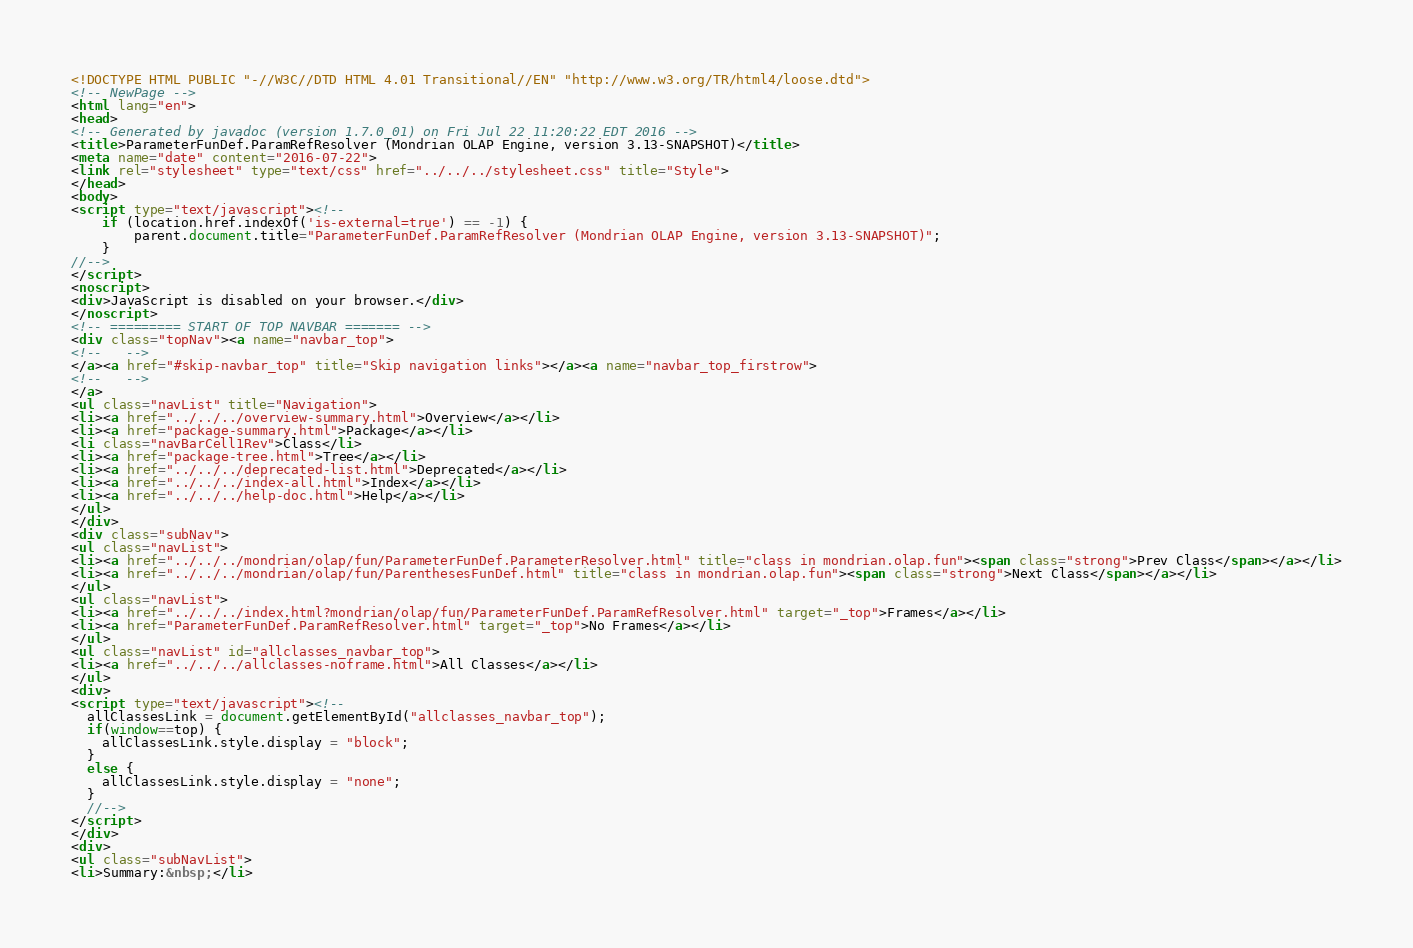<code> <loc_0><loc_0><loc_500><loc_500><_HTML_><!DOCTYPE HTML PUBLIC "-//W3C//DTD HTML 4.01 Transitional//EN" "http://www.w3.org/TR/html4/loose.dtd">
<!-- NewPage -->
<html lang="en">
<head>
<!-- Generated by javadoc (version 1.7.0_01) on Fri Jul 22 11:20:22 EDT 2016 -->
<title>ParameterFunDef.ParamRefResolver (Mondrian OLAP Engine, version 3.13-SNAPSHOT)</title>
<meta name="date" content="2016-07-22">
<link rel="stylesheet" type="text/css" href="../../../stylesheet.css" title="Style">
</head>
<body>
<script type="text/javascript"><!--
    if (location.href.indexOf('is-external=true') == -1) {
        parent.document.title="ParameterFunDef.ParamRefResolver (Mondrian OLAP Engine, version 3.13-SNAPSHOT)";
    }
//-->
</script>
<noscript>
<div>JavaScript is disabled on your browser.</div>
</noscript>
<!-- ========= START OF TOP NAVBAR ======= -->
<div class="topNav"><a name="navbar_top">
<!--   -->
</a><a href="#skip-navbar_top" title="Skip navigation links"></a><a name="navbar_top_firstrow">
<!--   -->
</a>
<ul class="navList" title="Navigation">
<li><a href="../../../overview-summary.html">Overview</a></li>
<li><a href="package-summary.html">Package</a></li>
<li class="navBarCell1Rev">Class</li>
<li><a href="package-tree.html">Tree</a></li>
<li><a href="../../../deprecated-list.html">Deprecated</a></li>
<li><a href="../../../index-all.html">Index</a></li>
<li><a href="../../../help-doc.html">Help</a></li>
</ul>
</div>
<div class="subNav">
<ul class="navList">
<li><a href="../../../mondrian/olap/fun/ParameterFunDef.ParameterResolver.html" title="class in mondrian.olap.fun"><span class="strong">Prev Class</span></a></li>
<li><a href="../../../mondrian/olap/fun/ParenthesesFunDef.html" title="class in mondrian.olap.fun"><span class="strong">Next Class</span></a></li>
</ul>
<ul class="navList">
<li><a href="../../../index.html?mondrian/olap/fun/ParameterFunDef.ParamRefResolver.html" target="_top">Frames</a></li>
<li><a href="ParameterFunDef.ParamRefResolver.html" target="_top">No Frames</a></li>
</ul>
<ul class="navList" id="allclasses_navbar_top">
<li><a href="../../../allclasses-noframe.html">All Classes</a></li>
</ul>
<div>
<script type="text/javascript"><!--
  allClassesLink = document.getElementById("allclasses_navbar_top");
  if(window==top) {
    allClassesLink.style.display = "block";
  }
  else {
    allClassesLink.style.display = "none";
  }
  //-->
</script>
</div>
<div>
<ul class="subNavList">
<li>Summary:&nbsp;</li></code> 